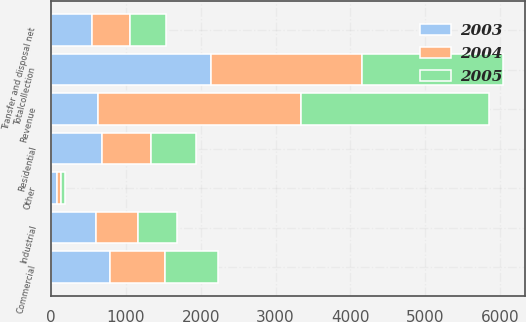<chart> <loc_0><loc_0><loc_500><loc_500><stacked_bar_chart><ecel><fcel>Residential<fcel>Commercial<fcel>Industrial<fcel>Other<fcel>Totalcollection<fcel>Transfer and disposal net<fcel>Revenue<nl><fcel>2003<fcel>683.6<fcel>781.1<fcel>597.8<fcel>76.6<fcel>2139.1<fcel>548.5<fcel>628.2<nl><fcel>2004<fcel>655.2<fcel>737.9<fcel>558.1<fcel>62.2<fcel>2013.4<fcel>511.2<fcel>2708.1<nl><fcel>2005<fcel>601.2<fcel>706<fcel>523<fcel>50.9<fcel>1881.1<fcel>473.8<fcel>2517.8<nl></chart> 